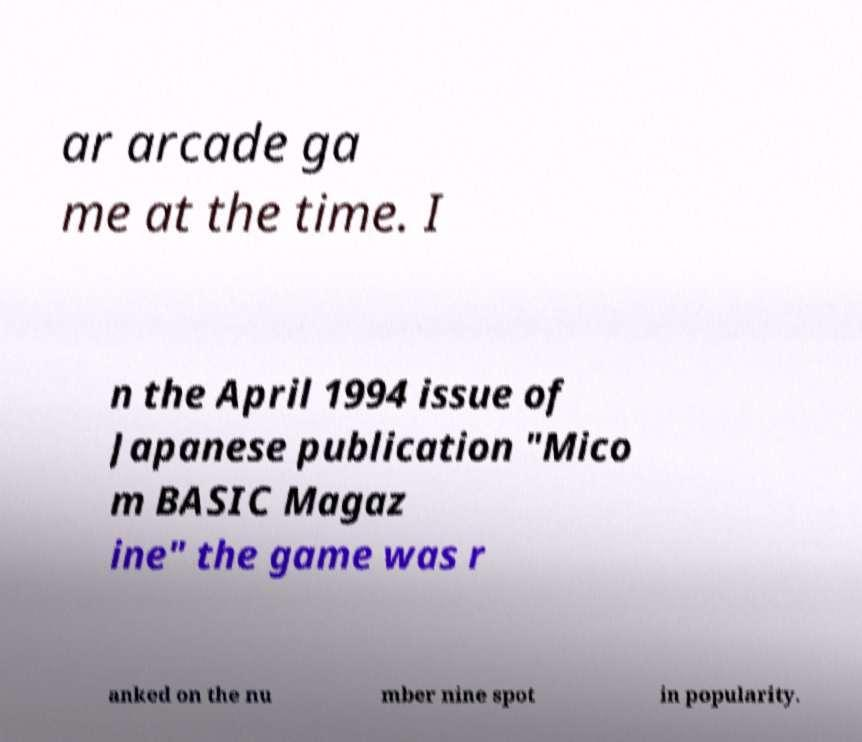Please identify and transcribe the text found in this image. ar arcade ga me at the time. I n the April 1994 issue of Japanese publication "Mico m BASIC Magaz ine" the game was r anked on the nu mber nine spot in popularity. 